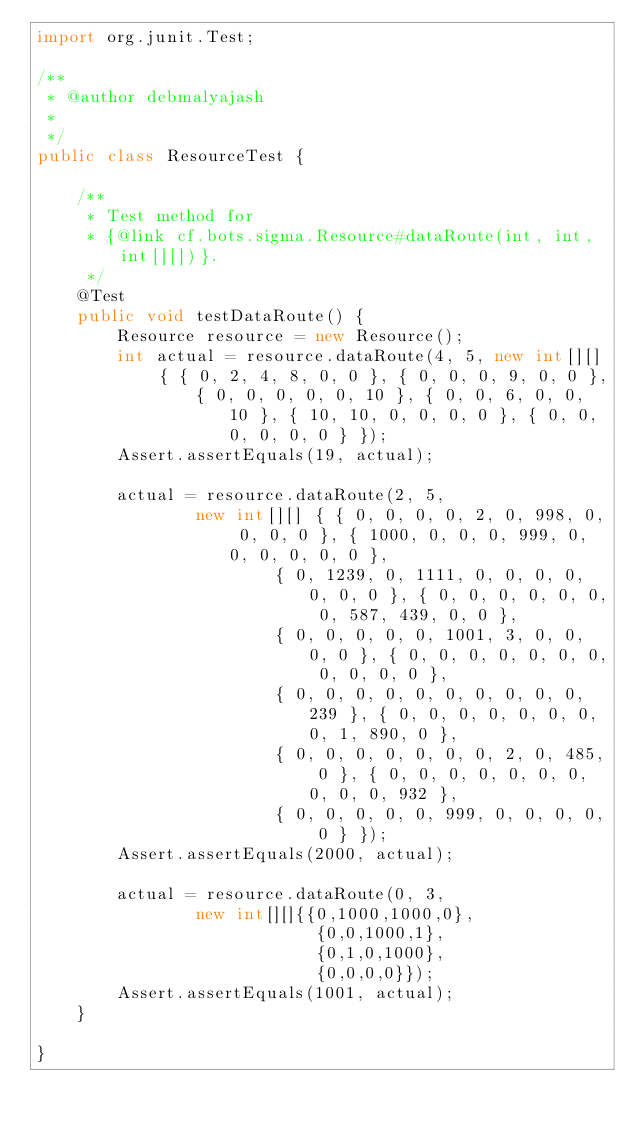Convert code to text. <code><loc_0><loc_0><loc_500><loc_500><_Java_>import org.junit.Test;

/**
 * @author debmalyajash
 *
 */
public class ResourceTest {

	/**
	 * Test method for
	 * {@link cf.bots.sigma.Resource#dataRoute(int, int, int[][])}.
	 */
	@Test
	public void testDataRoute() {
		Resource resource = new Resource();
		int actual = resource.dataRoute(4, 5, new int[][] { { 0, 2, 4, 8, 0, 0 }, { 0, 0, 0, 9, 0, 0 },
				{ 0, 0, 0, 0, 0, 10 }, { 0, 0, 6, 0, 0, 10 }, { 10, 10, 0, 0, 0, 0 }, { 0, 0, 0, 0, 0, 0 } });
		Assert.assertEquals(19, actual);

		actual = resource.dataRoute(2, 5,
				new int[][] { { 0, 0, 0, 0, 2, 0, 998, 0, 0, 0, 0 }, { 1000, 0, 0, 0, 999, 0, 0, 0, 0, 0, 0 },
						{ 0, 1239, 0, 1111, 0, 0, 0, 0, 0, 0, 0 }, { 0, 0, 0, 0, 0, 0, 0, 587, 439, 0, 0 },
						{ 0, 0, 0, 0, 0, 1001, 3, 0, 0, 0, 0 }, { 0, 0, 0, 0, 0, 0, 0, 0, 0, 0, 0 },
						{ 0, 0, 0, 0, 0, 0, 0, 0, 0, 0, 239 }, { 0, 0, 0, 0, 0, 0, 0, 0, 1, 890, 0 },
						{ 0, 0, 0, 0, 0, 0, 0, 2, 0, 485, 0 }, { 0, 0, 0, 0, 0, 0, 0, 0, 0, 0, 932 },
						{ 0, 0, 0, 0, 0, 999, 0, 0, 0, 0, 0 } });
		Assert.assertEquals(2000, actual);
		
		actual = resource.dataRoute(0, 3,
				new int[][]{{0,1000,1000,0}, 
				            {0,0,1000,1}, 
				            {0,1,0,1000}, 
				            {0,0,0,0}});
		Assert.assertEquals(1001, actual);
	}

}
</code> 